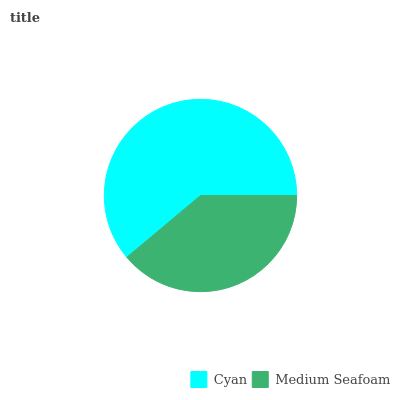Is Medium Seafoam the minimum?
Answer yes or no. Yes. Is Cyan the maximum?
Answer yes or no. Yes. Is Medium Seafoam the maximum?
Answer yes or no. No. Is Cyan greater than Medium Seafoam?
Answer yes or no. Yes. Is Medium Seafoam less than Cyan?
Answer yes or no. Yes. Is Medium Seafoam greater than Cyan?
Answer yes or no. No. Is Cyan less than Medium Seafoam?
Answer yes or no. No. Is Cyan the high median?
Answer yes or no. Yes. Is Medium Seafoam the low median?
Answer yes or no. Yes. Is Medium Seafoam the high median?
Answer yes or no. No. Is Cyan the low median?
Answer yes or no. No. 